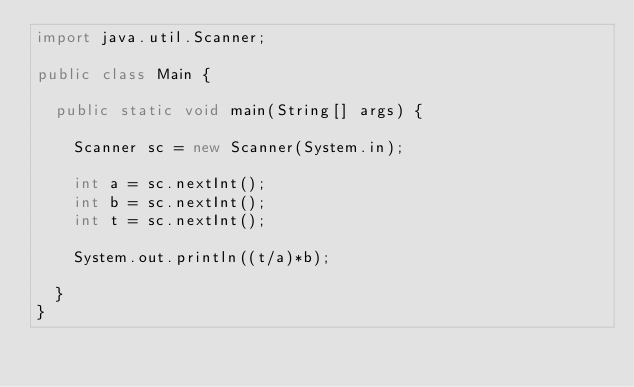Convert code to text. <code><loc_0><loc_0><loc_500><loc_500><_Java_>import java.util.Scanner;

public class Main {
	
	public static void main(String[] args) {

		Scanner sc = new Scanner(System.in);
		
		int a = sc.nextInt();
		int b = sc.nextInt();
		int t = sc.nextInt();
		
		System.out.println((t/a)*b);
		
	}
}
</code> 